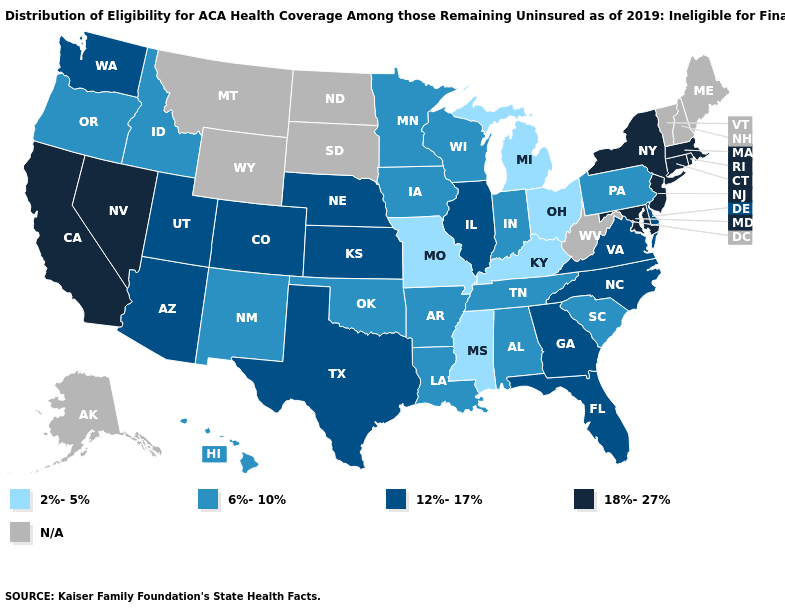Among the states that border Wyoming , which have the lowest value?
Give a very brief answer. Idaho. Which states hav the highest value in the MidWest?
Give a very brief answer. Illinois, Kansas, Nebraska. What is the value of Alaska?
Keep it brief. N/A. What is the lowest value in the Northeast?
Write a very short answer. 6%-10%. What is the value of Nebraska?
Concise answer only. 12%-17%. What is the lowest value in states that border Virginia?
Keep it brief. 2%-5%. Does the map have missing data?
Concise answer only. Yes. Which states have the lowest value in the USA?
Answer briefly. Kentucky, Michigan, Mississippi, Missouri, Ohio. How many symbols are there in the legend?
Give a very brief answer. 5. Which states hav the highest value in the Northeast?
Short answer required. Connecticut, Massachusetts, New Jersey, New York, Rhode Island. Does Minnesota have the lowest value in the MidWest?
Give a very brief answer. No. Name the states that have a value in the range 12%-17%?
Quick response, please. Arizona, Colorado, Delaware, Florida, Georgia, Illinois, Kansas, Nebraska, North Carolina, Texas, Utah, Virginia, Washington. Among the states that border New Jersey , does New York have the highest value?
Quick response, please. Yes. 